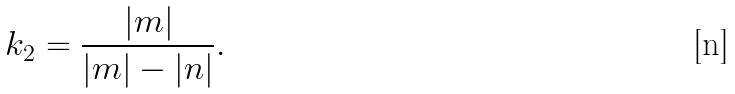Convert formula to latex. <formula><loc_0><loc_0><loc_500><loc_500>k _ { 2 } = \frac { | m | } { | m | - | n | } .</formula> 